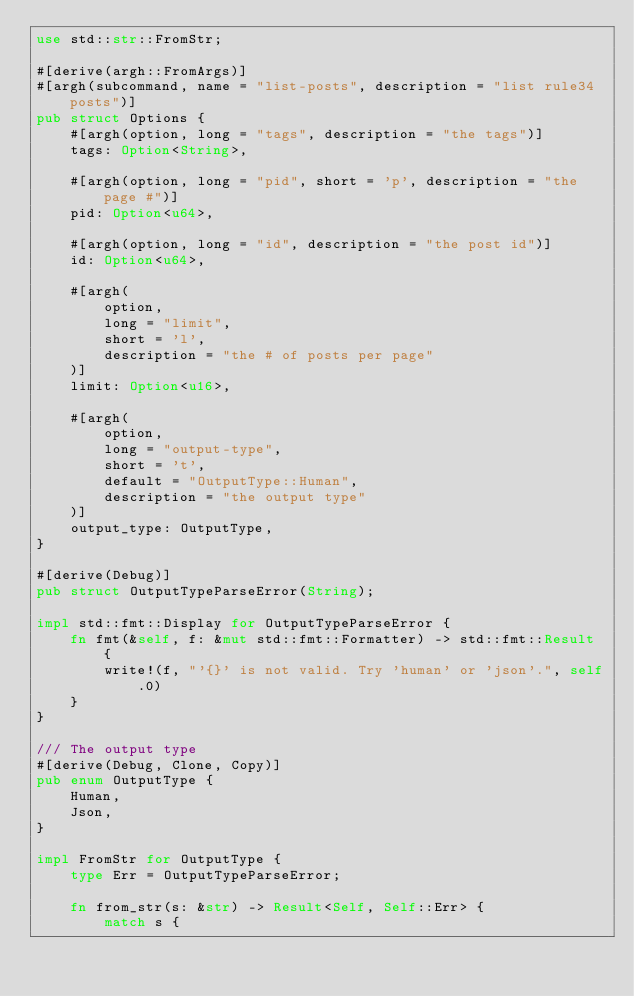Convert code to text. <code><loc_0><loc_0><loc_500><loc_500><_Rust_>use std::str::FromStr;

#[derive(argh::FromArgs)]
#[argh(subcommand, name = "list-posts", description = "list rule34 posts")]
pub struct Options {
    #[argh(option, long = "tags", description = "the tags")]
    tags: Option<String>,

    #[argh(option, long = "pid", short = 'p', description = "the page #")]
    pid: Option<u64>,

    #[argh(option, long = "id", description = "the post id")]
    id: Option<u64>,

    #[argh(
        option,
        long = "limit",
        short = 'l',
        description = "the # of posts per page"
    )]
    limit: Option<u16>,

    #[argh(
        option,
        long = "output-type",
        short = 't',
        default = "OutputType::Human",
        description = "the output type"
    )]
    output_type: OutputType,
}

#[derive(Debug)]
pub struct OutputTypeParseError(String);

impl std::fmt::Display for OutputTypeParseError {
    fn fmt(&self, f: &mut std::fmt::Formatter) -> std::fmt::Result {
        write!(f, "'{}' is not valid. Try 'human' or 'json'.", self.0)
    }
}

/// The output type
#[derive(Debug, Clone, Copy)]
pub enum OutputType {
    Human,
    Json,
}

impl FromStr for OutputType {
    type Err = OutputTypeParseError;

    fn from_str(s: &str) -> Result<Self, Self::Err> {
        match s {</code> 